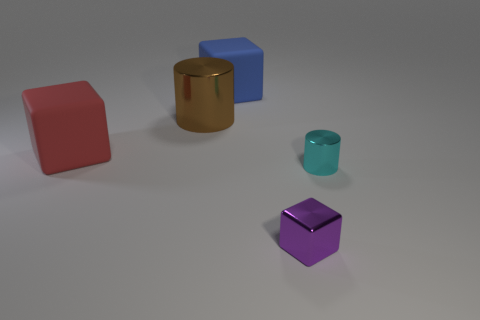There is a metallic object that is behind the small purple metal block and to the left of the cyan metallic object; what is its shape?
Provide a short and direct response. Cylinder. How many other things are the same shape as the big blue thing?
Provide a short and direct response. 2. What is the color of the rubber object that is the same size as the blue block?
Ensure brevity in your answer.  Red. How many objects are either large green matte balls or blocks?
Make the answer very short. 3. There is a tiny cube; are there any shiny objects behind it?
Your response must be concise. Yes. Is there a brown thing that has the same material as the large blue thing?
Your response must be concise. No. What number of cylinders are either metal things or purple shiny things?
Ensure brevity in your answer.  2. Are there more small cyan metal cylinders behind the big red block than blue cubes on the right side of the purple block?
Ensure brevity in your answer.  No. What number of big blocks have the same color as the tiny cylinder?
Your answer should be compact. 0. There is a purple thing that is the same material as the small cyan cylinder; what size is it?
Keep it short and to the point. Small. 